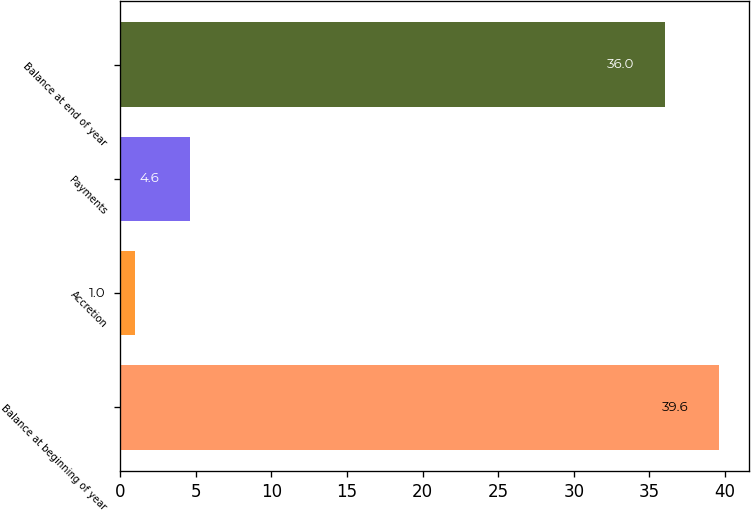Convert chart to OTSL. <chart><loc_0><loc_0><loc_500><loc_500><bar_chart><fcel>Balance at beginning of year<fcel>Accretion<fcel>Payments<fcel>Balance at end of year<nl><fcel>39.6<fcel>1<fcel>4.6<fcel>36<nl></chart> 